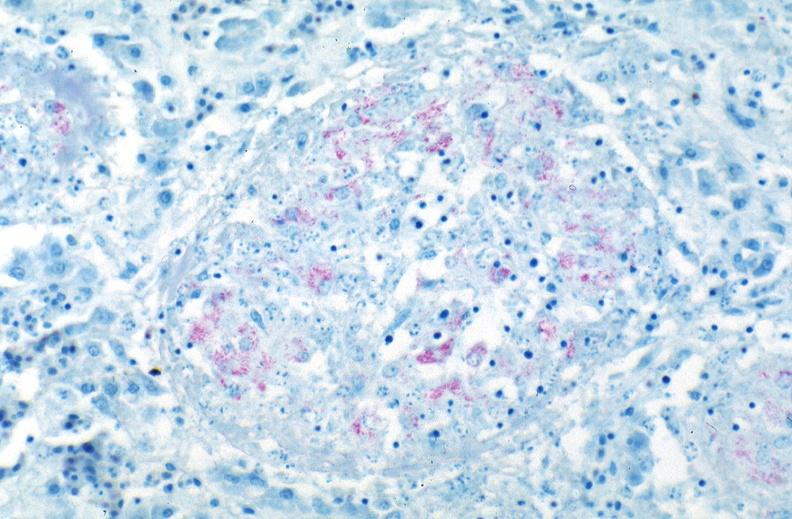where is this?
Answer the question using a single word or phrase. Lung 